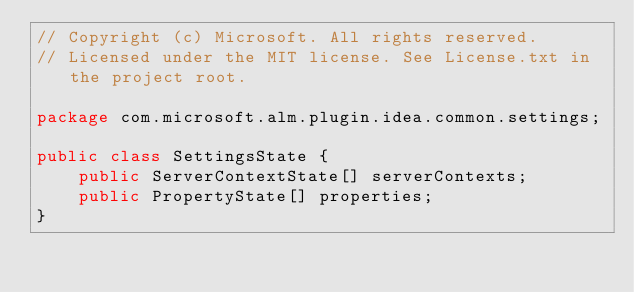Convert code to text. <code><loc_0><loc_0><loc_500><loc_500><_Java_>// Copyright (c) Microsoft. All rights reserved.
// Licensed under the MIT license. See License.txt in the project root.

package com.microsoft.alm.plugin.idea.common.settings;

public class SettingsState {
    public ServerContextState[] serverContexts;
    public PropertyState[] properties;
}
</code> 